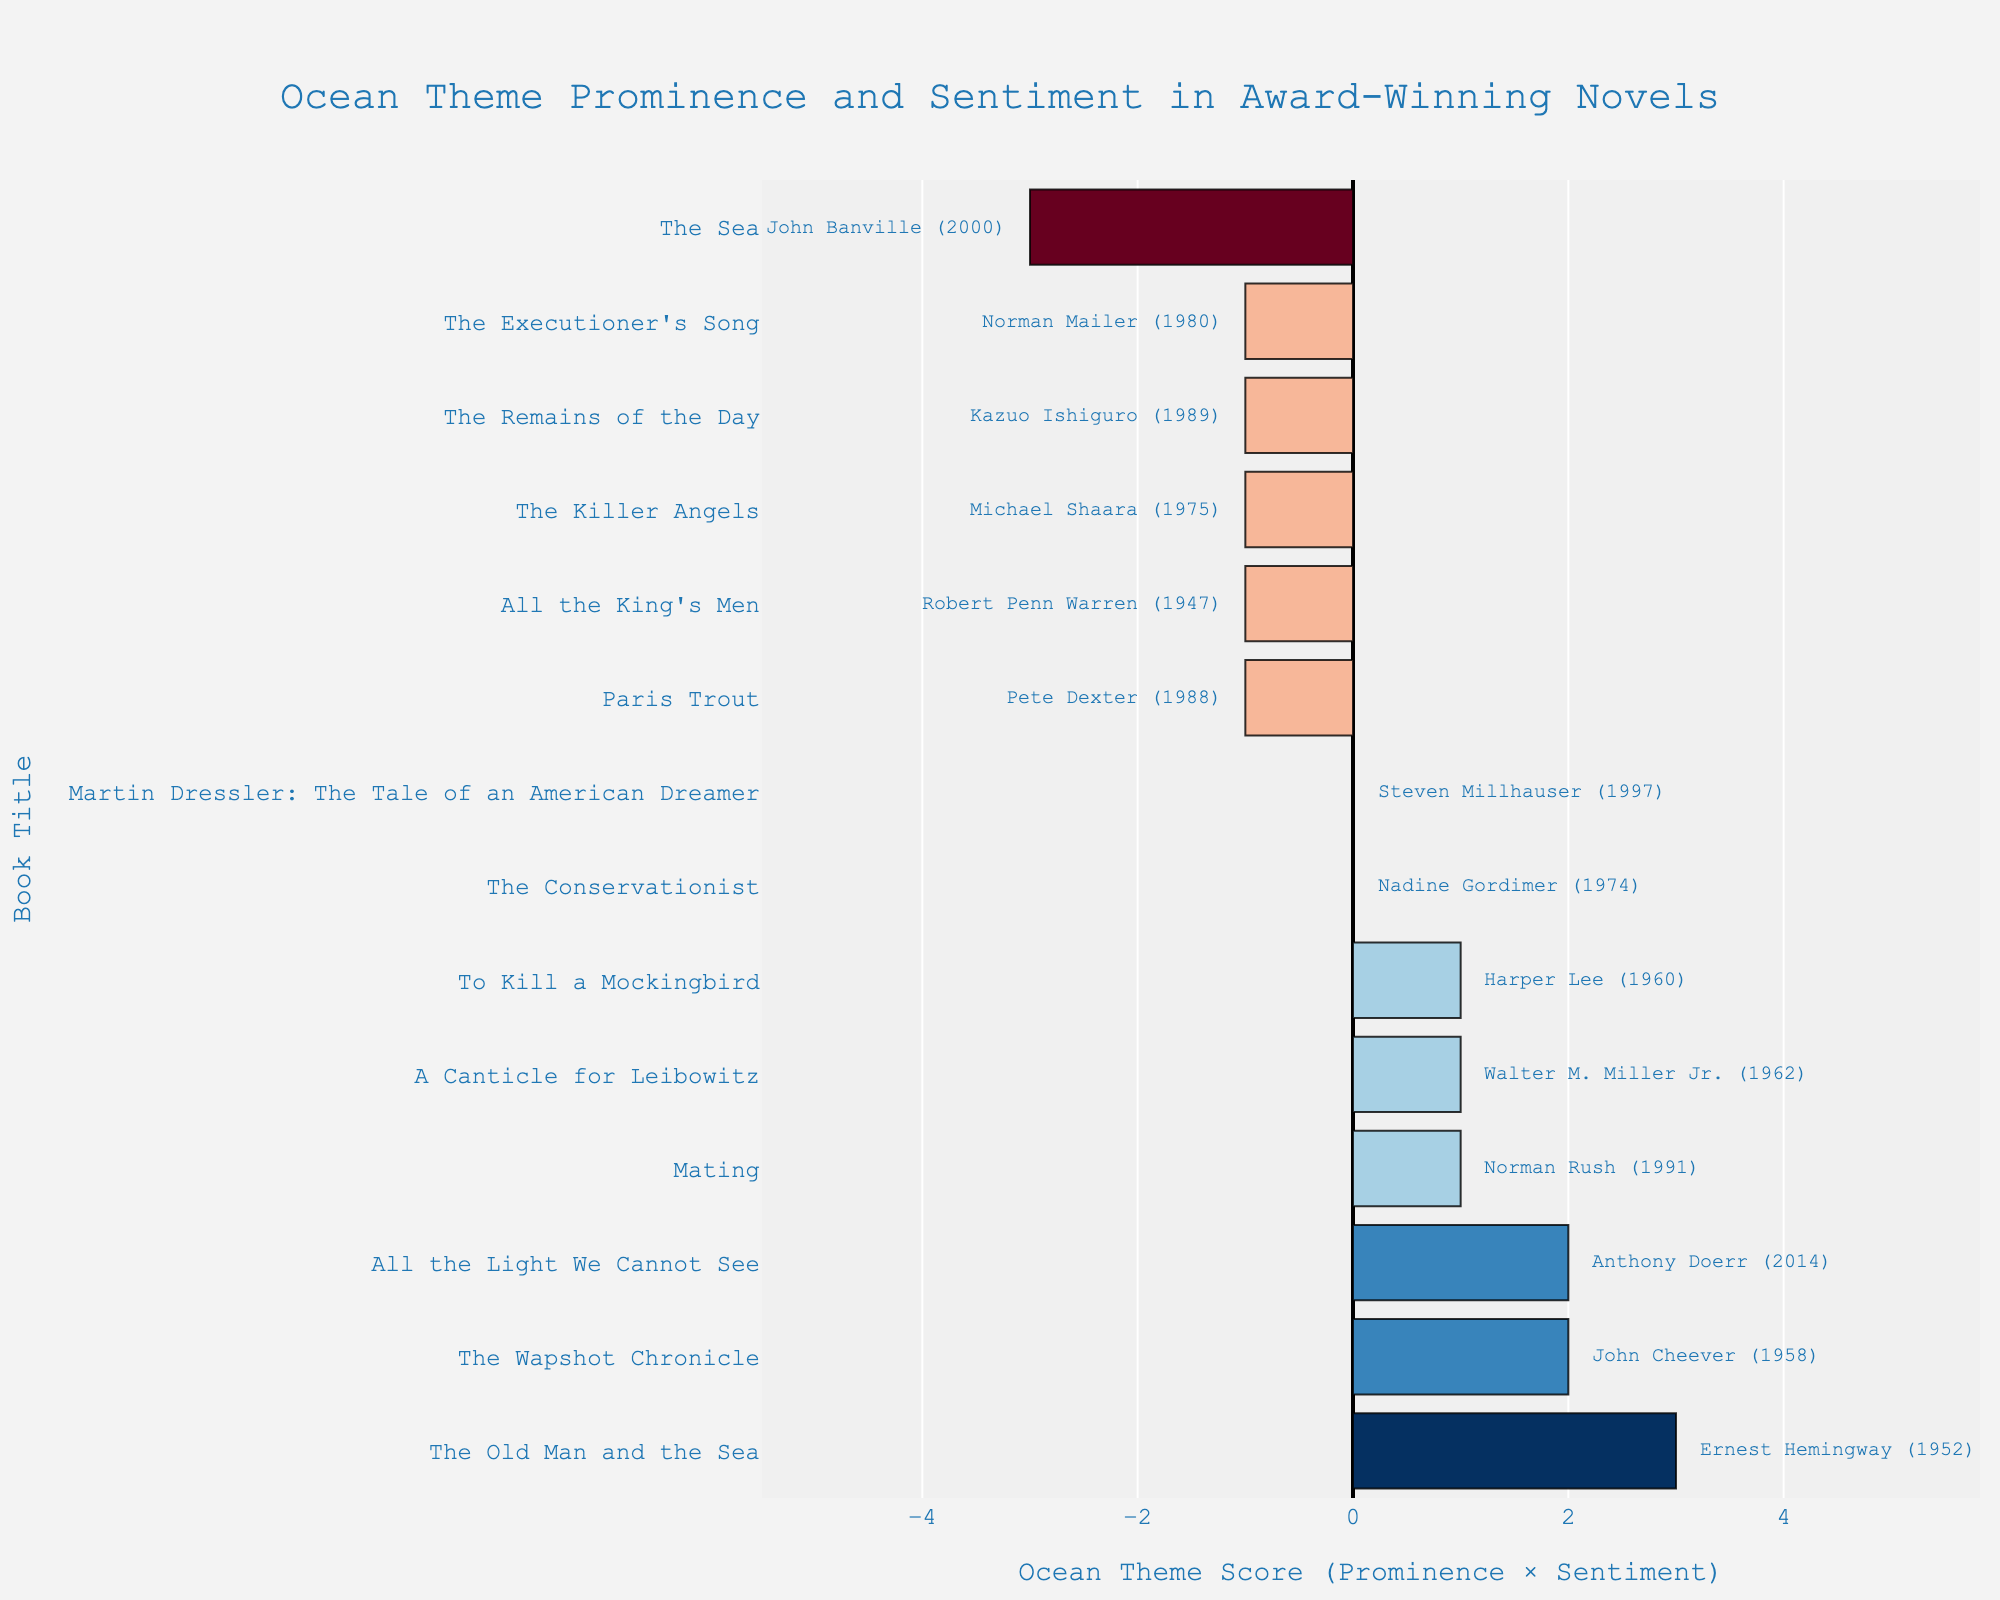Which book has the highest positive score related to ocean setting? The highest positive score is indicated by the rightmost bar in the chart with a positive value. In this case, it is "The Old Man and the Sea" by Ernest Hemingway with a score of 3.
Answer: The Old Man and the Sea Which book has the most negative sentiment towards the ocean setting? The most negative sentiment towards the ocean setting is shown by the leftmost bar with the highest negative score. "The Sea" by John Banville has a score of -3.
Answer: The Sea Between "All the Light We Cannot See" and "The Wapshot Chronicle," which has a higher combined score? Examine the position of the two books on the horizontal axis. "The Wapshot Chronicle" has a combined score of +2, while "All the Light We Cannot See" has a combined score of +2. Both books have an equal combined score of +2.
Answer: Both are equal What is the combined score of "Paris Trout"? Locate "Paris Trout" on the chart and look at its position on the horizontal axis to determine the combined score. The combined score for "Paris Trout" is -1.
Answer: -1 Which book by Kazuo Ishiguro is represented, and what is its sentiment and ocean setting score? Locate the book by Kazuo Ishiguro, "The Remains of the Day." It is on the left side of the chart with a combined score of -1. The sentiment is negative, and the ocean setting prominence is low. Therefore, the ocean setting score is 1, and the sentiment score is -1, giving a combined score of -1.
Answer: The Remains of the Day; Negative Sentiment; Low Ocean Setting Compare the combined scores of "To Kill a Mockingbird" and "The Killer Angels." Which scores higher? "To Kill a Mockingbird" has a score of +1, while "The Killer Angels" has a score of -1. Therefore, "To Kill a Mockingbird" scores higher.
Answer: To Kill a Mockingbird Which book has a neutral sentiment and what is its ocean setting prominence? Look for bars that are colored around the central axis with a combined score of 0, representing neutral sentiment. "Martin Dressler: The Tale of an American Dreamer" and "The Conservationist" both have neutral scores. Their ocean setting prominence is low.
Answer: Martin Dressler: The Tale of an American Dreamer and The Conservationist; Low Ocean Setting 